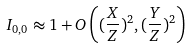Convert formula to latex. <formula><loc_0><loc_0><loc_500><loc_500>I _ { 0 , 0 } \approx 1 + O \left ( ( \frac { X } { Z } ) ^ { 2 } , ( \frac { Y } { Z } ) ^ { 2 } \right )</formula> 